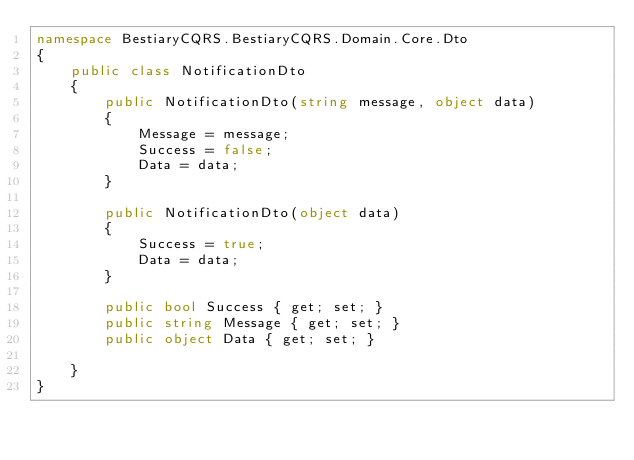Convert code to text. <code><loc_0><loc_0><loc_500><loc_500><_C#_>namespace BestiaryCQRS.BestiaryCQRS.Domain.Core.Dto
{
    public class NotificationDto
    {
        public NotificationDto(string message, object data)
        {
            Message = message;
            Success = false;
            Data = data;
        }

        public NotificationDto(object data)
        {
            Success = true;
            Data = data;
        }

        public bool Success { get; set; }
        public string Message { get; set; }
        public object Data { get; set; }

    }
}</code> 